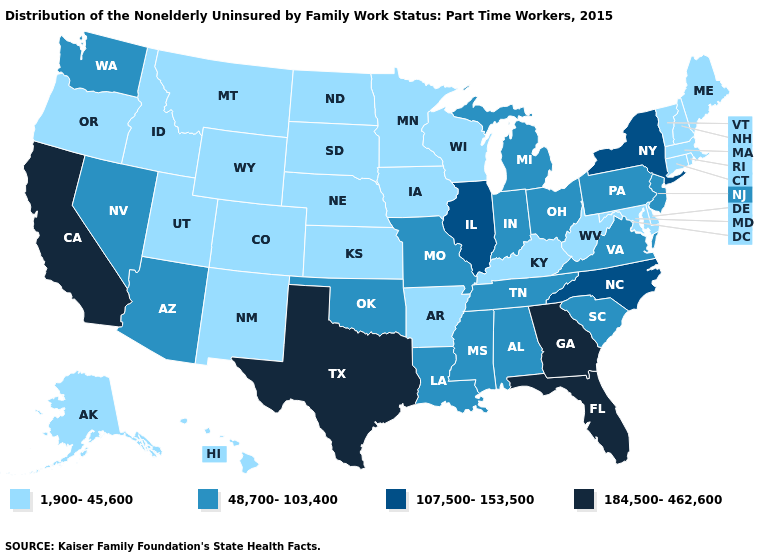What is the value of Oregon?
Be succinct. 1,900-45,600. Name the states that have a value in the range 48,700-103,400?
Give a very brief answer. Alabama, Arizona, Indiana, Louisiana, Michigan, Mississippi, Missouri, Nevada, New Jersey, Ohio, Oklahoma, Pennsylvania, South Carolina, Tennessee, Virginia, Washington. What is the lowest value in the USA?
Quick response, please. 1,900-45,600. Which states have the lowest value in the MidWest?
Keep it brief. Iowa, Kansas, Minnesota, Nebraska, North Dakota, South Dakota, Wisconsin. What is the highest value in the West ?
Concise answer only. 184,500-462,600. What is the value of Pennsylvania?
Quick response, please. 48,700-103,400. Name the states that have a value in the range 184,500-462,600?
Short answer required. California, Florida, Georgia, Texas. Which states have the highest value in the USA?
Short answer required. California, Florida, Georgia, Texas. Name the states that have a value in the range 48,700-103,400?
Short answer required. Alabama, Arizona, Indiana, Louisiana, Michigan, Mississippi, Missouri, Nevada, New Jersey, Ohio, Oklahoma, Pennsylvania, South Carolina, Tennessee, Virginia, Washington. Does Arkansas have the same value as Montana?
Short answer required. Yes. Name the states that have a value in the range 1,900-45,600?
Write a very short answer. Alaska, Arkansas, Colorado, Connecticut, Delaware, Hawaii, Idaho, Iowa, Kansas, Kentucky, Maine, Maryland, Massachusetts, Minnesota, Montana, Nebraska, New Hampshire, New Mexico, North Dakota, Oregon, Rhode Island, South Dakota, Utah, Vermont, West Virginia, Wisconsin, Wyoming. Does Vermont have the same value as Mississippi?
Concise answer only. No. Among the states that border Oregon , which have the lowest value?
Keep it brief. Idaho. Which states hav the highest value in the South?
Short answer required. Florida, Georgia, Texas. 